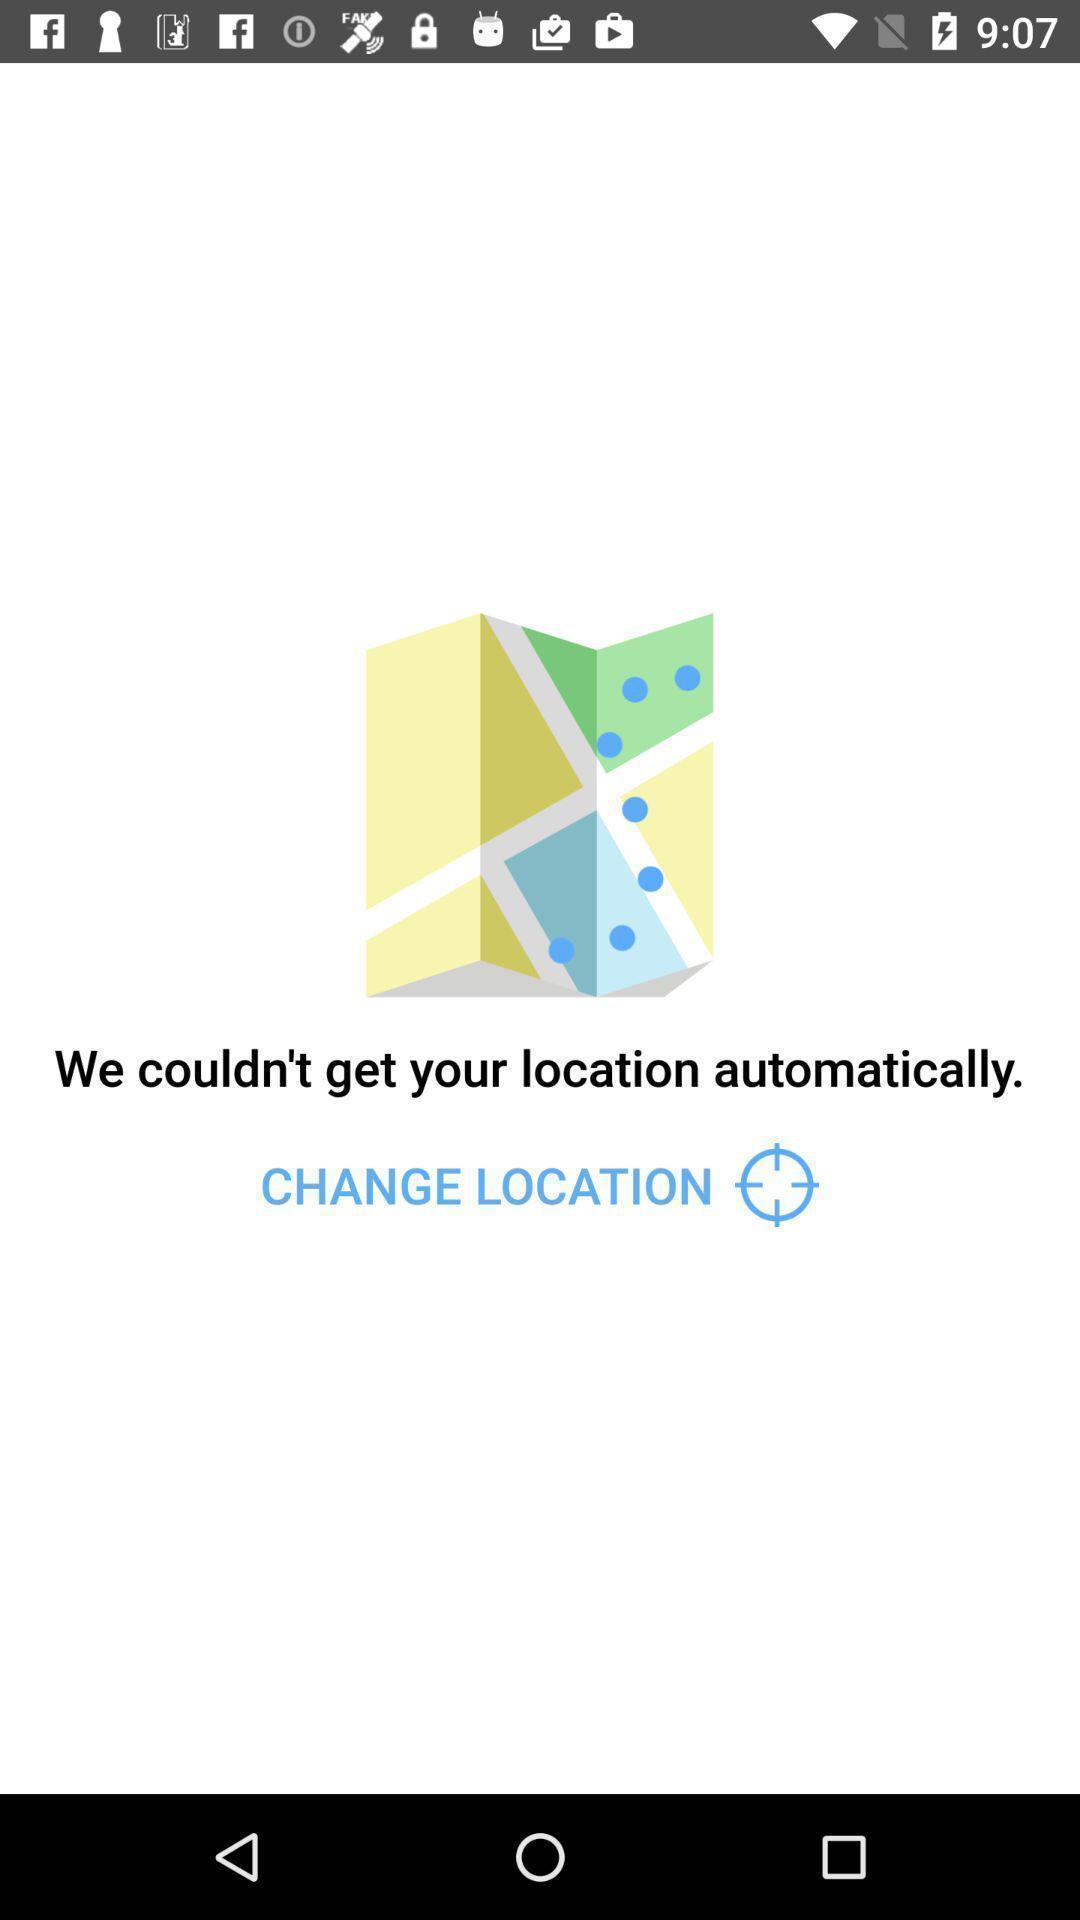Tell me about the visual elements in this screen capture. Screen shows we could n't get your location. 